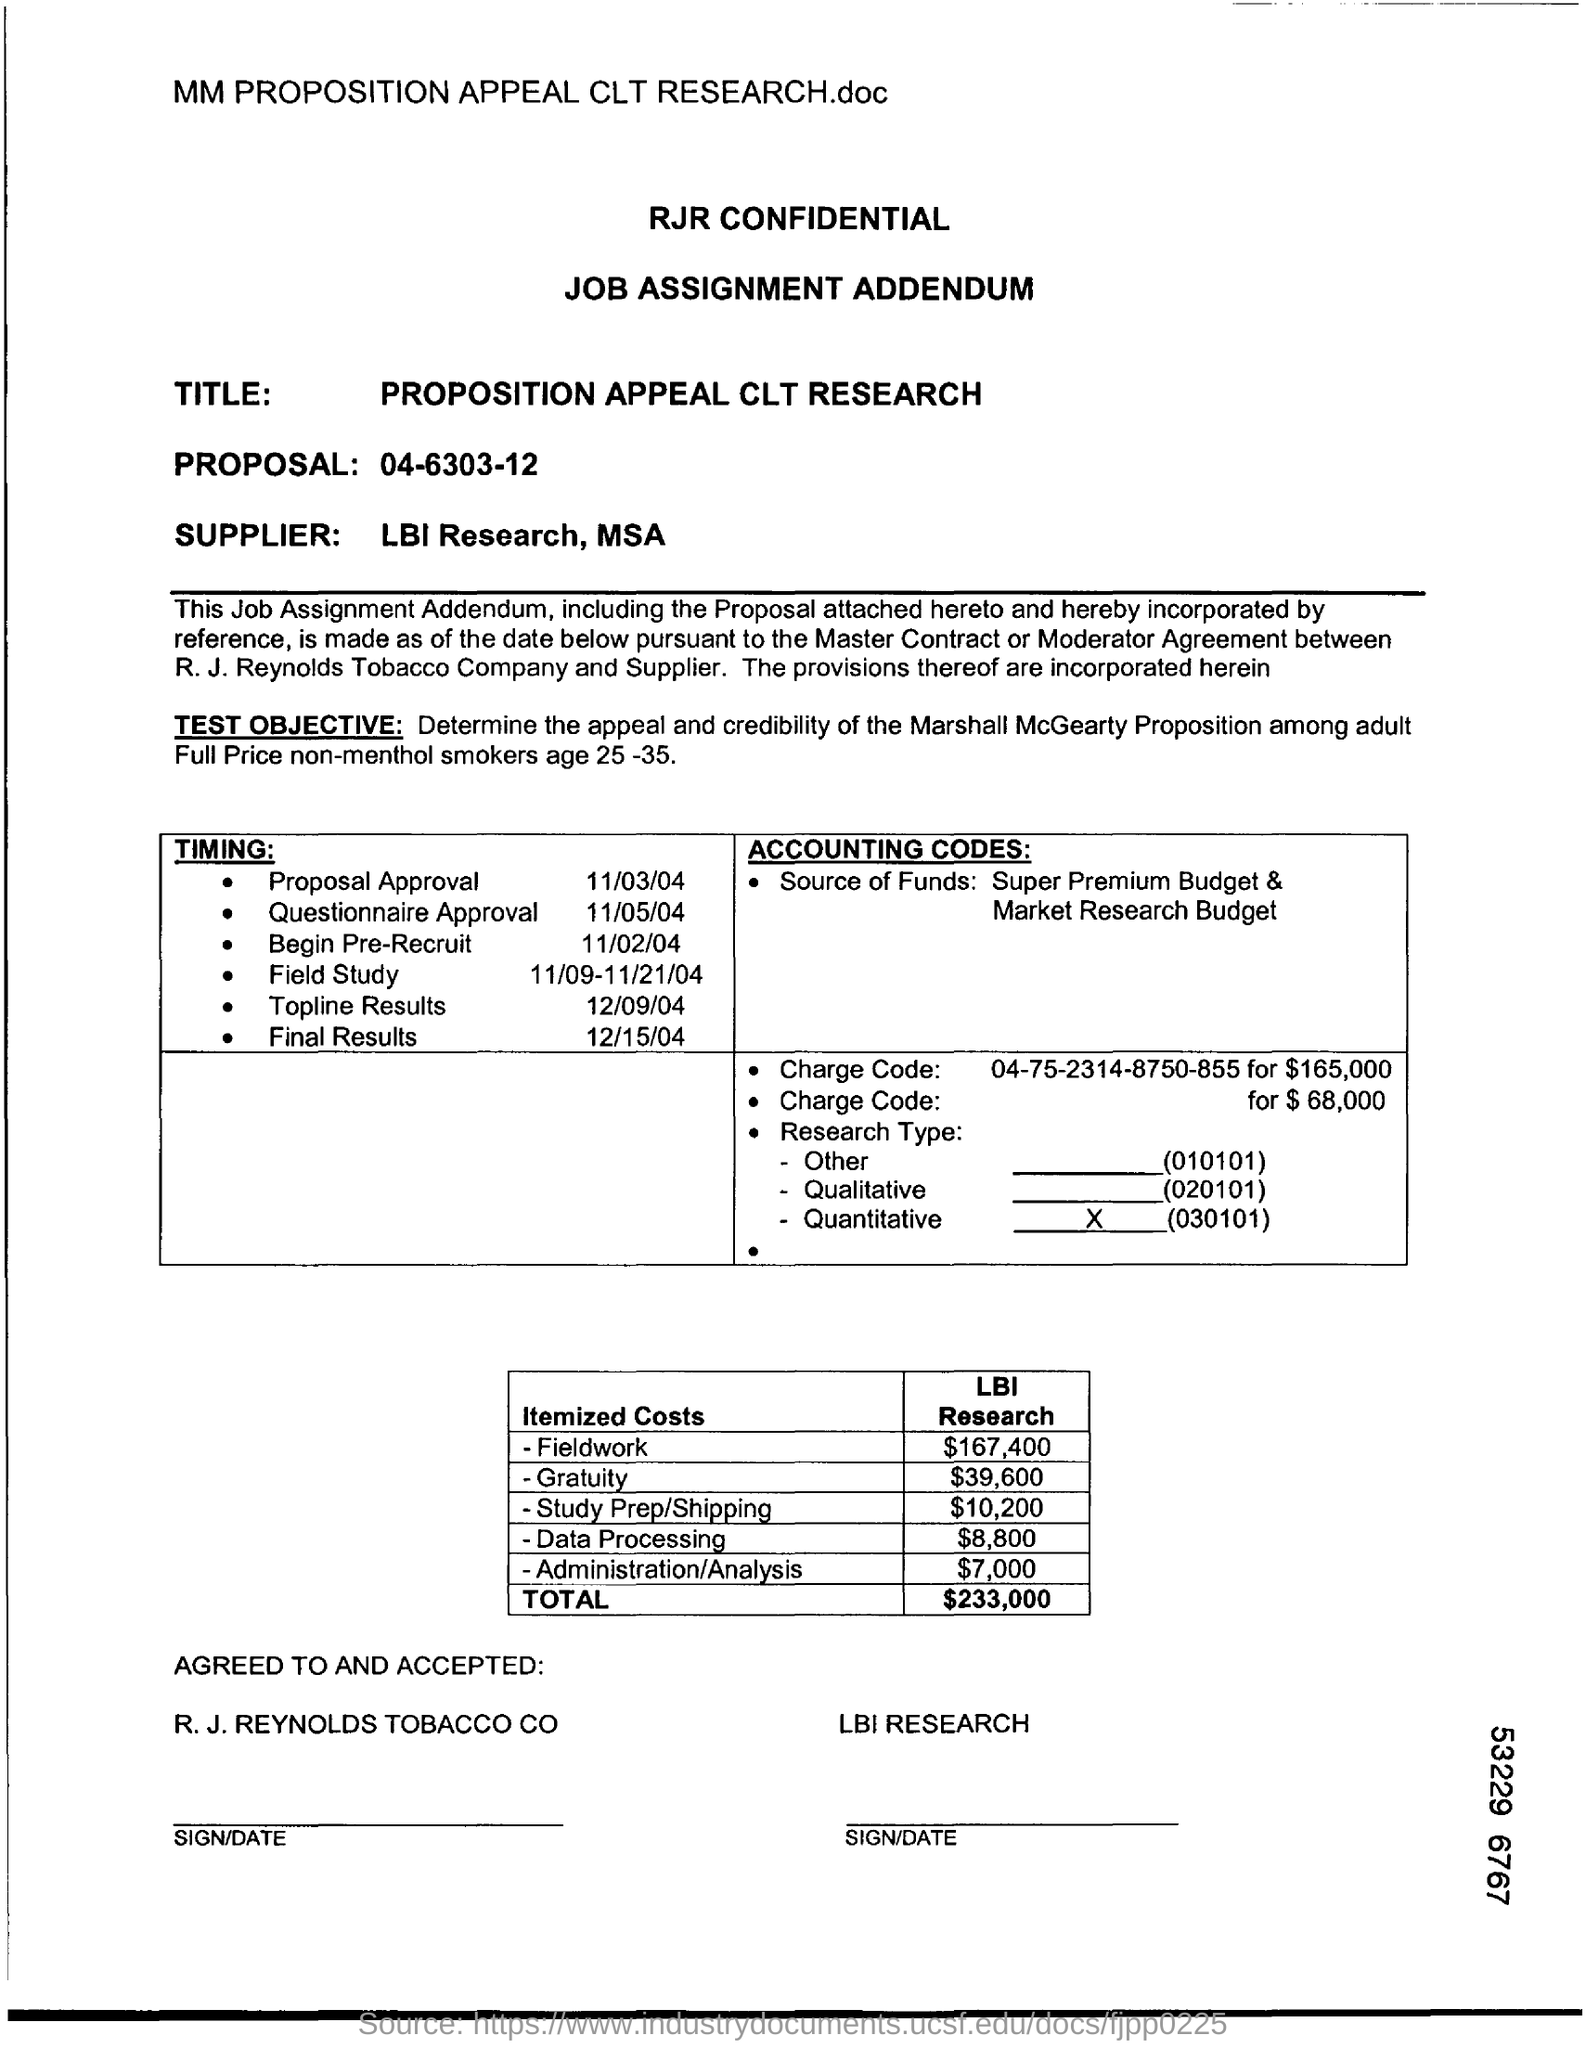Who is the supplier?
Provide a short and direct response. LBI Research, MSA. What is the "Timing" for "Topline Results"?
Offer a terse response. 12/09/04. What is the Itemized Costs for Data Processing?
Provide a short and direct response. $8,800. What is the "Timing" for "Proposal Approval"?
Offer a terse response. 11/03/04. 